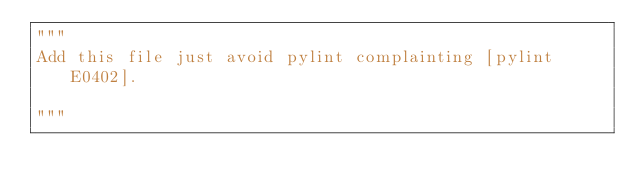Convert code to text. <code><loc_0><loc_0><loc_500><loc_500><_Python_>"""
Add this file just avoid pylint complainting [pylint E0402].

"""
</code> 